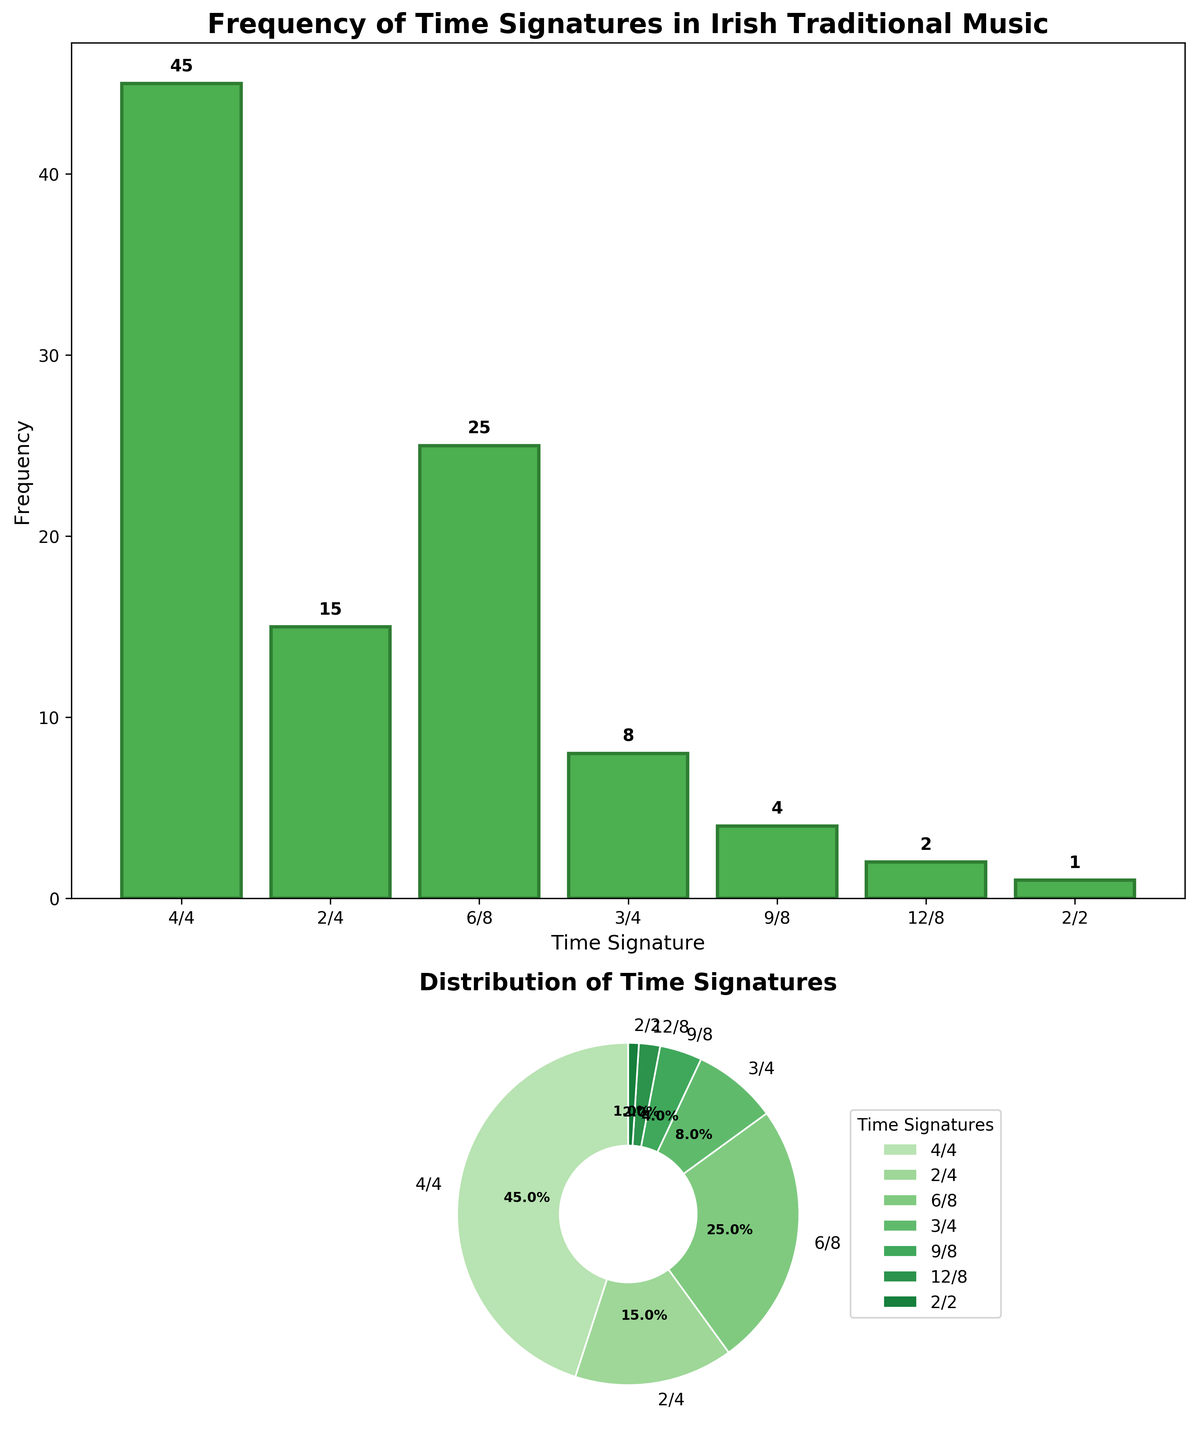What is the most common time signature in Irish traditional music according to the bar plot? The bar plot shows that the 4/4 time signature has the highest bar, indicating it is the most common with a frequency of 45.
Answer: 4/4 Which two time signatures have the same height in the bar plot? The bars for 9/8 and 12/8 have similar heights, indicating that they have similar frequencies. The frequency of 9/8 is 4, and the frequency of 12/8 is 2.
Answer: None What is the combined frequency of the two least common time signatures? The least common time signatures are 2/2 and 12/8 with frequencies of 1 and 2, respectively. Adding these together, 1 + 2 = 3.
Answer: 3 Which time signature comprises exactly one-quarter (25%) of the total compositions in the pie chart? In the pie chart, the 4/4 time signature covers exactly 25% of the chart, showing it comprises one-quarter of the compositions.
Answer: 4/4 How does the frequency of 6/8 compare to the frequency of 2/4? The frequency of 6/8 is 25, while the frequency of 2/4 is 15. This shows that 6/8 is more frequent than 2/4.
Answer: 6/8 is more frequent What proportion of compositions use a compound time signature (i.e., 6/8, 9/8, 12/8)? The frequencies of compound time signatures (6/8, 9/8, 12/8) are 25, 4, and 2 respectively. Summing these: 25 + 4 + 2 = 31. Dividing by the total frequency: 45 + 15 + 25 + 8 + 4 + 2 + 1 = 100, the proportion is 31/100 = 31%.
Answer: 31% Which time signature has a visual wedge color that is the most similar to the pie chart's green theme? In the pie chart, all wedges are shades of green, but the 4/4 wedge has the darkest shade, making it most prominent.
Answer: 4/4 What is the median frequency of the time signatures shown? The frequencies in ascending order are 1, 2, 4, 8, 15, 25, 45. The median frequency is the middle value in this ordered list, which is 8 (the value for 3/4).
Answer: 8 How many time signatures have a frequency higher than 10? From the bar plot, the time signatures with frequencies higher than 10 are 4/4 (45), 2/4 (15), and 6/8 (25). This gives a total of 3 time signatures.
Answer: 3 If the frequency of 2/4 and 6/8 were combined into a single category, what would be the new combined frequency and its rank among the time signatures? The combined frequency of 2/4 and 6/8 is 15 + 25 = 40. This would be lower than 4/4 (45) but higher than all other time signatures, making it the second most frequent.
Answer: 40, 2nd 